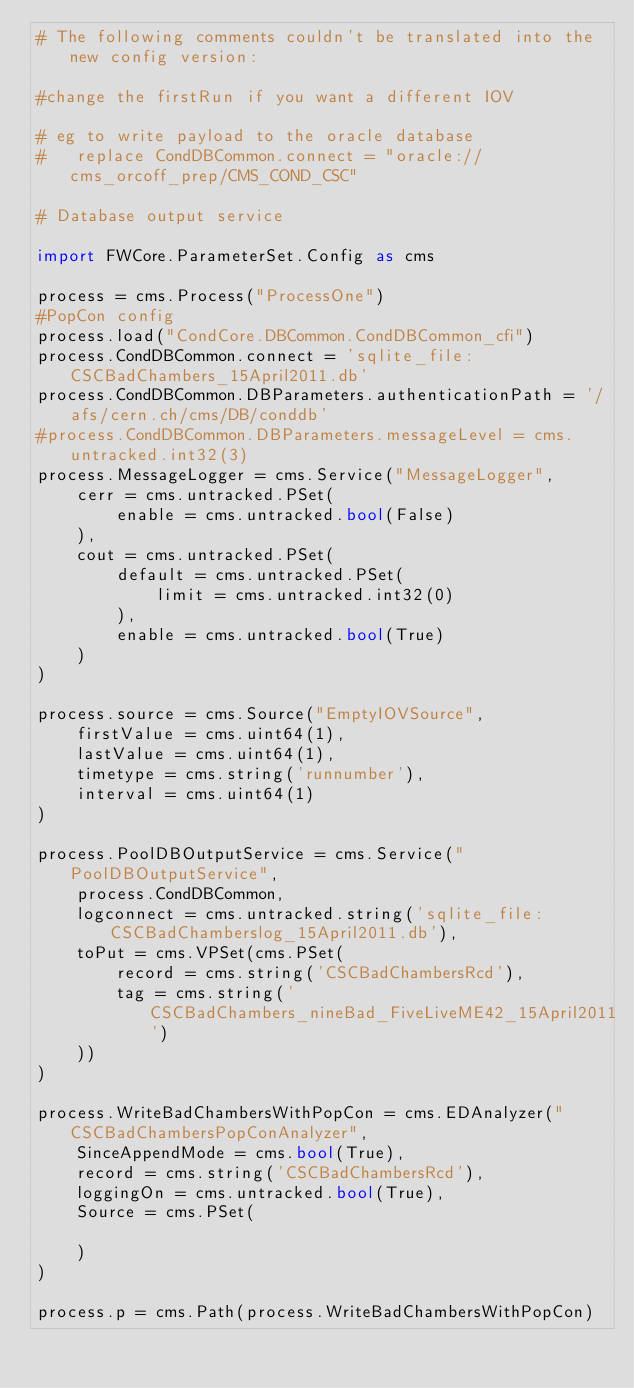<code> <loc_0><loc_0><loc_500><loc_500><_Python_># The following comments couldn't be translated into the new config version:

#change the firstRun if you want a different IOV

# eg to write payload to the oracle database 
#   replace CondDBCommon.connect = "oracle://cms_orcoff_prep/CMS_COND_CSC"

# Database output service

import FWCore.ParameterSet.Config as cms

process = cms.Process("ProcessOne")
#PopCon config
process.load("CondCore.DBCommon.CondDBCommon_cfi")
process.CondDBCommon.connect = 'sqlite_file:CSCBadChambers_15April2011.db'
process.CondDBCommon.DBParameters.authenticationPath = '/afs/cern.ch/cms/DB/conddb'
#process.CondDBCommon.DBParameters.messageLevel = cms.untracked.int32(3)
process.MessageLogger = cms.Service("MessageLogger",
    cerr = cms.untracked.PSet(
        enable = cms.untracked.bool(False)
    ),
    cout = cms.untracked.PSet(
        default = cms.untracked.PSet(
            limit = cms.untracked.int32(0)
        ),
        enable = cms.untracked.bool(True)
    )
)

process.source = cms.Source("EmptyIOVSource",
    firstValue = cms.uint64(1),
    lastValue = cms.uint64(1),
    timetype = cms.string('runnumber'),
    interval = cms.uint64(1)
)

process.PoolDBOutputService = cms.Service("PoolDBOutputService",
    process.CondDBCommon,
    logconnect = cms.untracked.string('sqlite_file:CSCBadChamberslog_15April2011.db'),
    toPut = cms.VPSet(cms.PSet(
        record = cms.string('CSCBadChambersRcd'),
        tag = cms.string('CSCBadChambers_nineBad_FiveLiveME42_15April2011')
    ))
)

process.WriteBadChambersWithPopCon = cms.EDAnalyzer("CSCBadChambersPopConAnalyzer",
    SinceAppendMode = cms.bool(True),
    record = cms.string('CSCBadChambersRcd'),
    loggingOn = cms.untracked.bool(True),
    Source = cms.PSet(

    )
)

process.p = cms.Path(process.WriteBadChambersWithPopCon)



</code> 